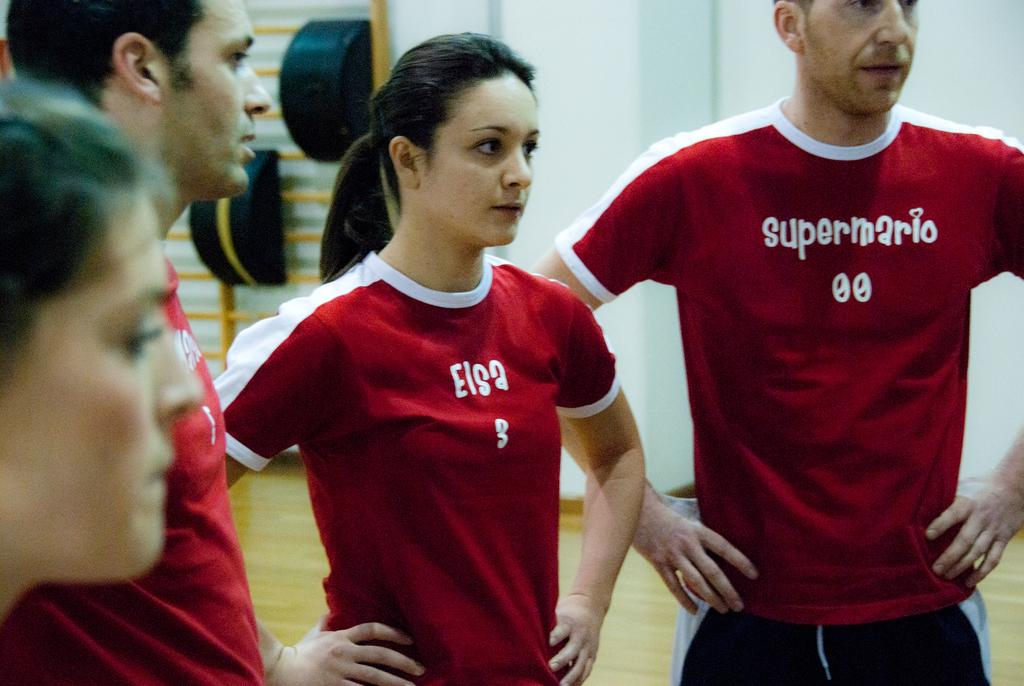<image>
Present a compact description of the photo's key features. Two men and two women are standing on a wood floor and wearing shirts that say super mario and Elsa. 